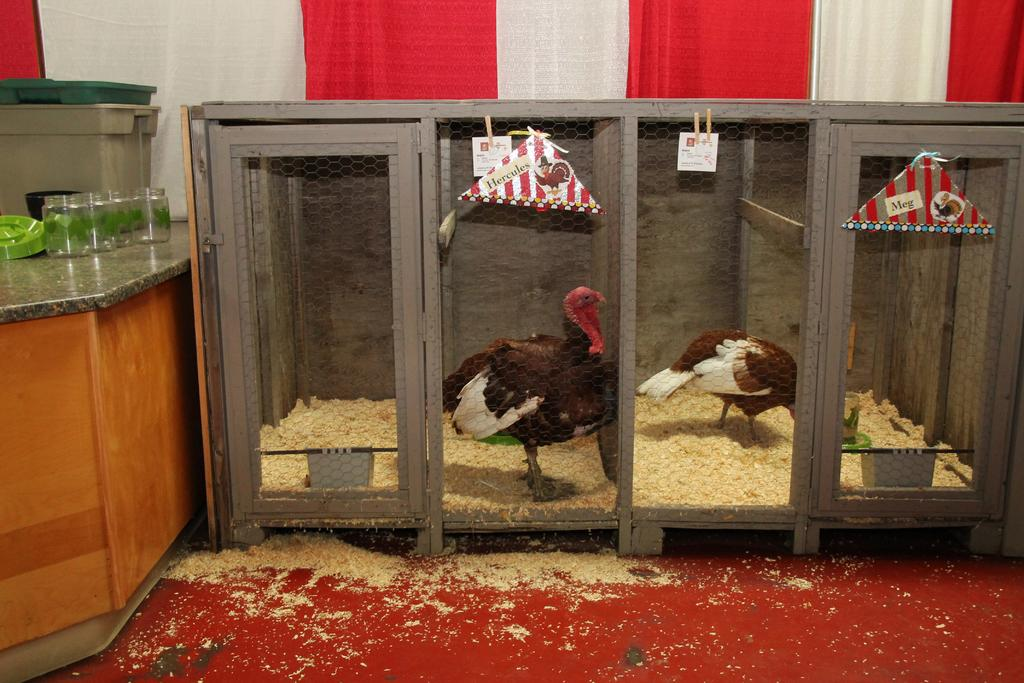What animals are in the image? There are birds in a cage in the image. What is located beside the cage? There is a cabinet beside the cage. What feature does the cabinet have? The cabinet has organizers on it. What items are on the cabinet? There are pet jars on the cabinet. What can be seen in the background of the image? There is a curtain in the background of the image. What type of wood can be seen on the edge of the elbow in the image? There is no wood, elbow, or any related objects present in the image. 